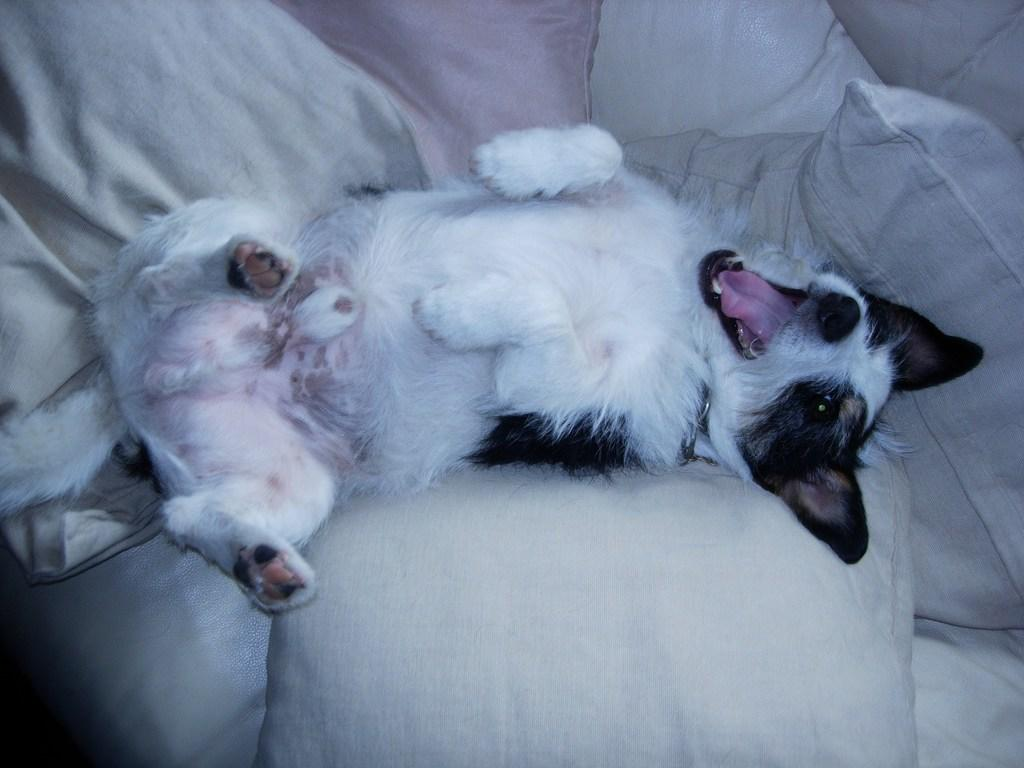What type of animal is in the image? There is a dog in the image. Where is the dog located? The dog is on a couch. What else can be seen on the couch? There are pillows on the couch. What type of tin can be seen next to the dog on the couch? There is no tin present in the image; it only features a dog on a couch with pillows. 